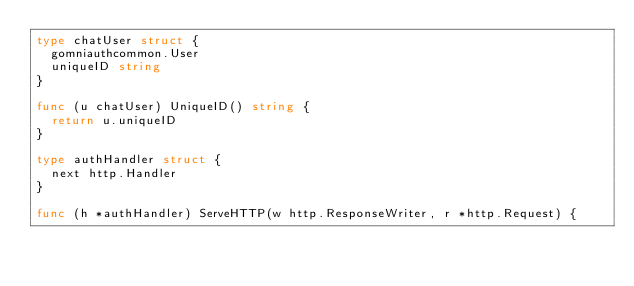Convert code to text. <code><loc_0><loc_0><loc_500><loc_500><_Go_>type chatUser struct {
	gomniauthcommon.User
	uniqueID string
}

func (u chatUser) UniqueID() string {
	return u.uniqueID
}

type authHandler struct {
	next http.Handler
}

func (h *authHandler) ServeHTTP(w http.ResponseWriter, r *http.Request) {</code> 